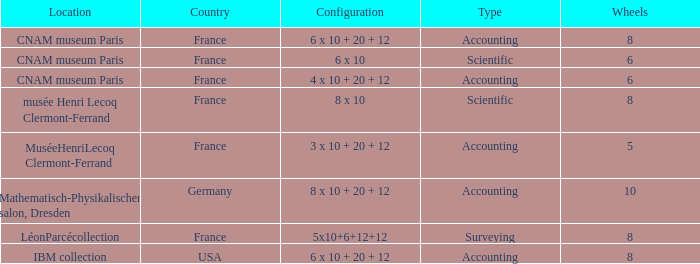What is the configuration for the country France, with accounting as the type, and wheels greater than 6? 6 x 10 + 20 + 12. 